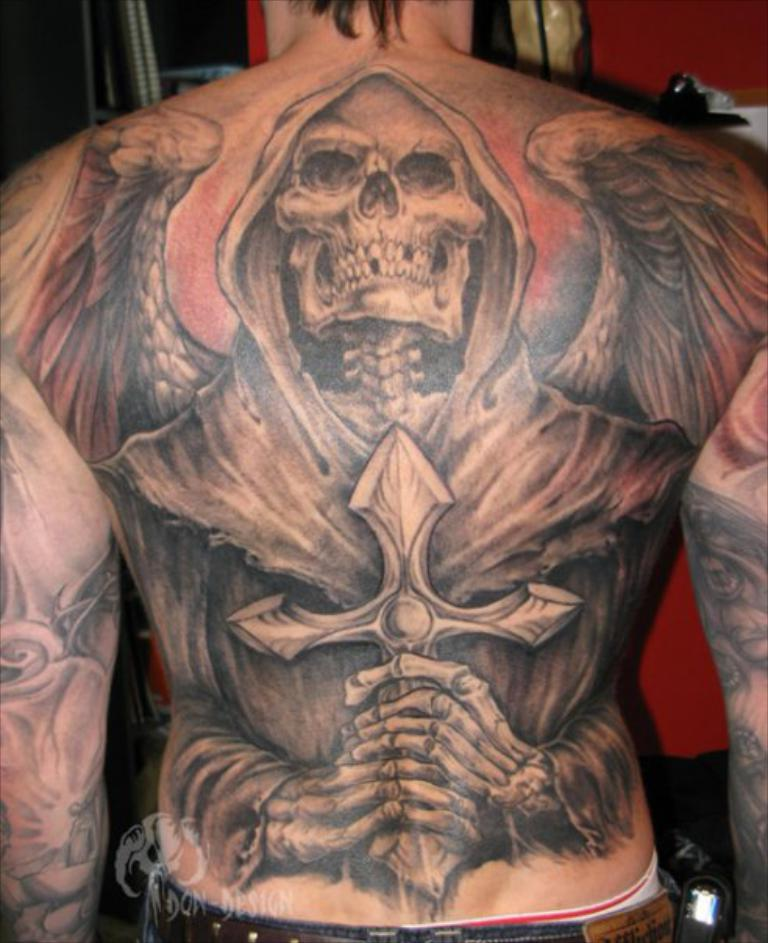What can be seen on the person's body in the image? There is a tattoo on a person's body in the image. What is visible in the background of the image? There is a wall and an object in the background of the image. What is located at the bottom of the image? There is a logo and text at the bottom of the image. How many flowers are present in the image? There are no flowers visible in the image. What is the rate of the tattoo artist in the image? There is no information about the tattoo artist's rate in the image. 